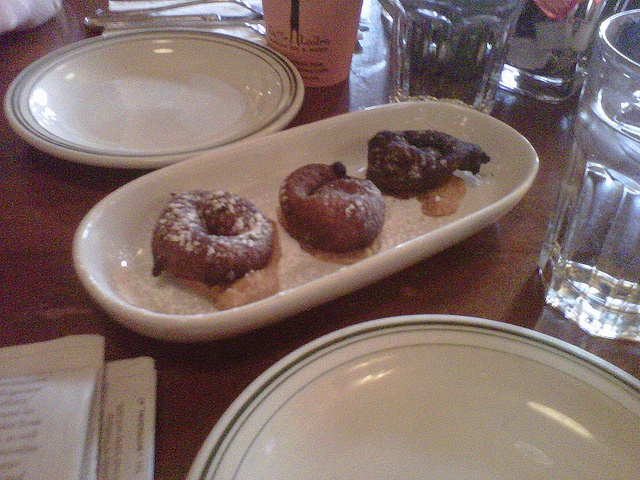Describe the objects in this image and their specific colors. I can see dining table in darkgray, gray, maroon, and black tones, bowl in lavender, gray, darkgray, and maroon tones, cup in lavender, gray, darkgray, and white tones, cup in lavender, gray, black, purple, and maroon tones, and donut in lavender, maroon, gray, brown, and darkgray tones in this image. 